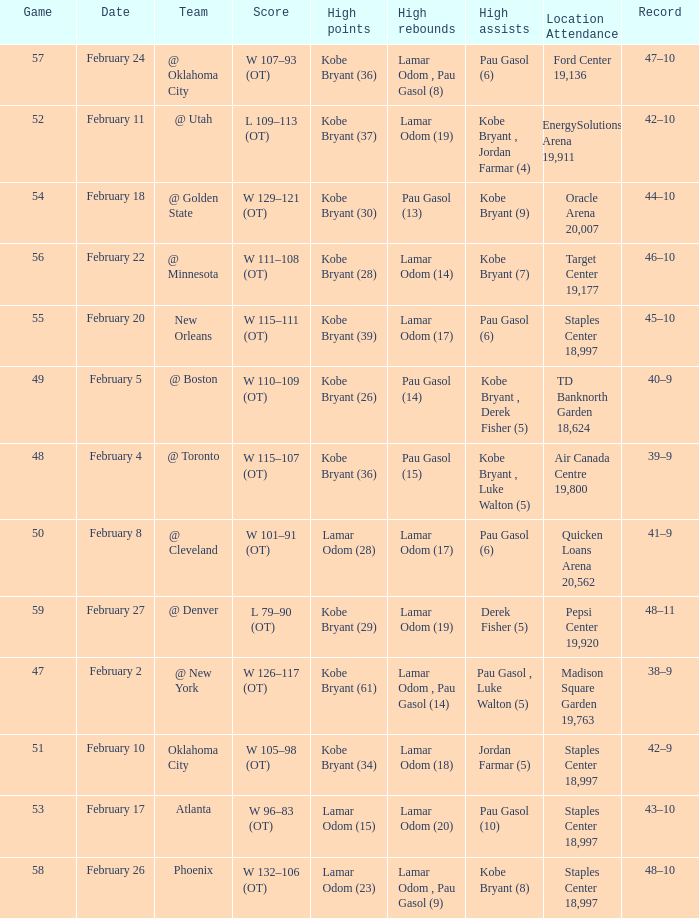Who had the most assists in the game against Atlanta? Pau Gasol (10). 